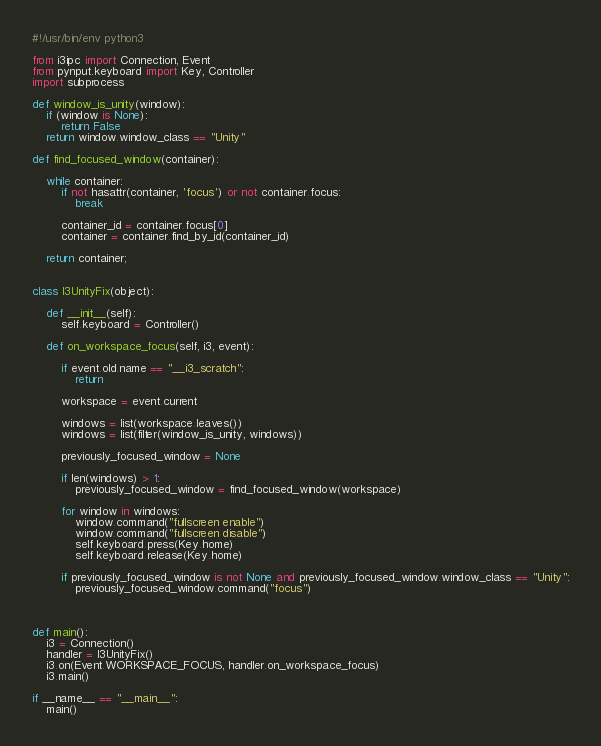<code> <loc_0><loc_0><loc_500><loc_500><_Python_>#!/usr/bin/env python3

from i3ipc import Connection, Event
from pynput.keyboard import Key, Controller
import subprocess

def window_is_unity(window):
    if (window is None):
        return False
    return window.window_class == "Unity"

def find_focused_window(container):

    while container:
        if not hasattr(container, 'focus') or not container.focus:
            break

        container_id = container.focus[0]
        container = container.find_by_id(container_id)
    
    return container;
        

class I3UnityFix(object):

    def __init__(self):
        self.keyboard = Controller()
        
    def on_workspace_focus(self, i3, event):

        if event.old.name == "__i3_scratch":
            return
            
        workspace = event.current

        windows = list(workspace.leaves())
        windows = list(filter(window_is_unity, windows))

        previously_focused_window = None

        if len(windows) > 1:
            previously_focused_window = find_focused_window(workspace)

        for window in windows:
            window.command("fullscreen enable")
            window.command("fullscreen disable")
            self.keyboard.press(Key.home)
            self.keyboard.release(Key.home)

        if previously_focused_window is not None and previously_focused_window.window_class == "Unity":
            previously_focused_window.command("focus")
        
	
            
def main():
    i3 = Connection()
    handler = I3UnityFix()
    i3.on(Event.WORKSPACE_FOCUS, handler.on_workspace_focus)
    i3.main()
    
if __name__ == "__main__":
    main()
</code> 